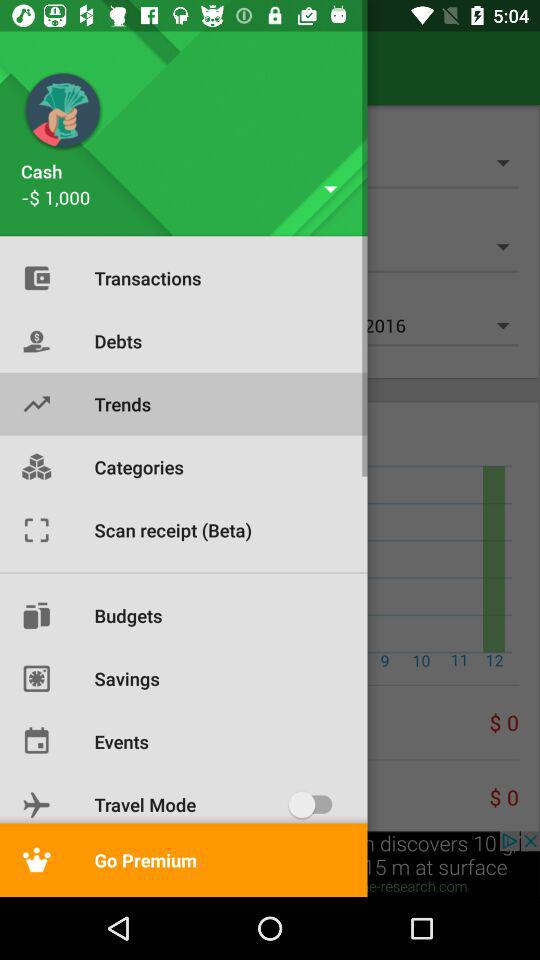What is the currency of the cash? The currency is dollars. 